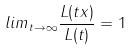Convert formula to latex. <formula><loc_0><loc_0><loc_500><loc_500>l i m _ { t \rightarrow \infty } \frac { L ( t x ) } { L ( t ) } = 1</formula> 